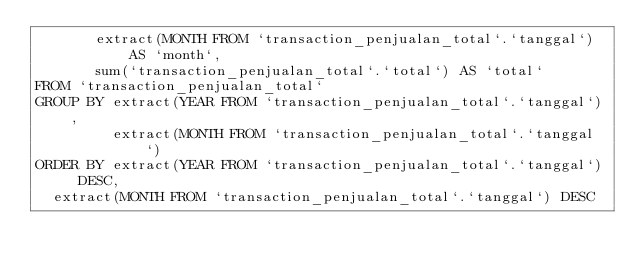Convert code to text. <code><loc_0><loc_0><loc_500><loc_500><_SQL_>       extract(MONTH FROM `transaction_penjualan_total`.`tanggal`) AS `month`,
       sum(`transaction_penjualan_total`.`total`) AS `total`
FROM `transaction_penjualan_total`
GROUP BY extract(YEAR FROM `transaction_penjualan_total`.`tanggal`),
         extract(MONTH FROM `transaction_penjualan_total`.`tanggal`)
ORDER BY extract(YEAR FROM `transaction_penjualan_total`.`tanggal`) DESC,
	extract(MONTH FROM `transaction_penjualan_total`.`tanggal`) DESC
</code> 